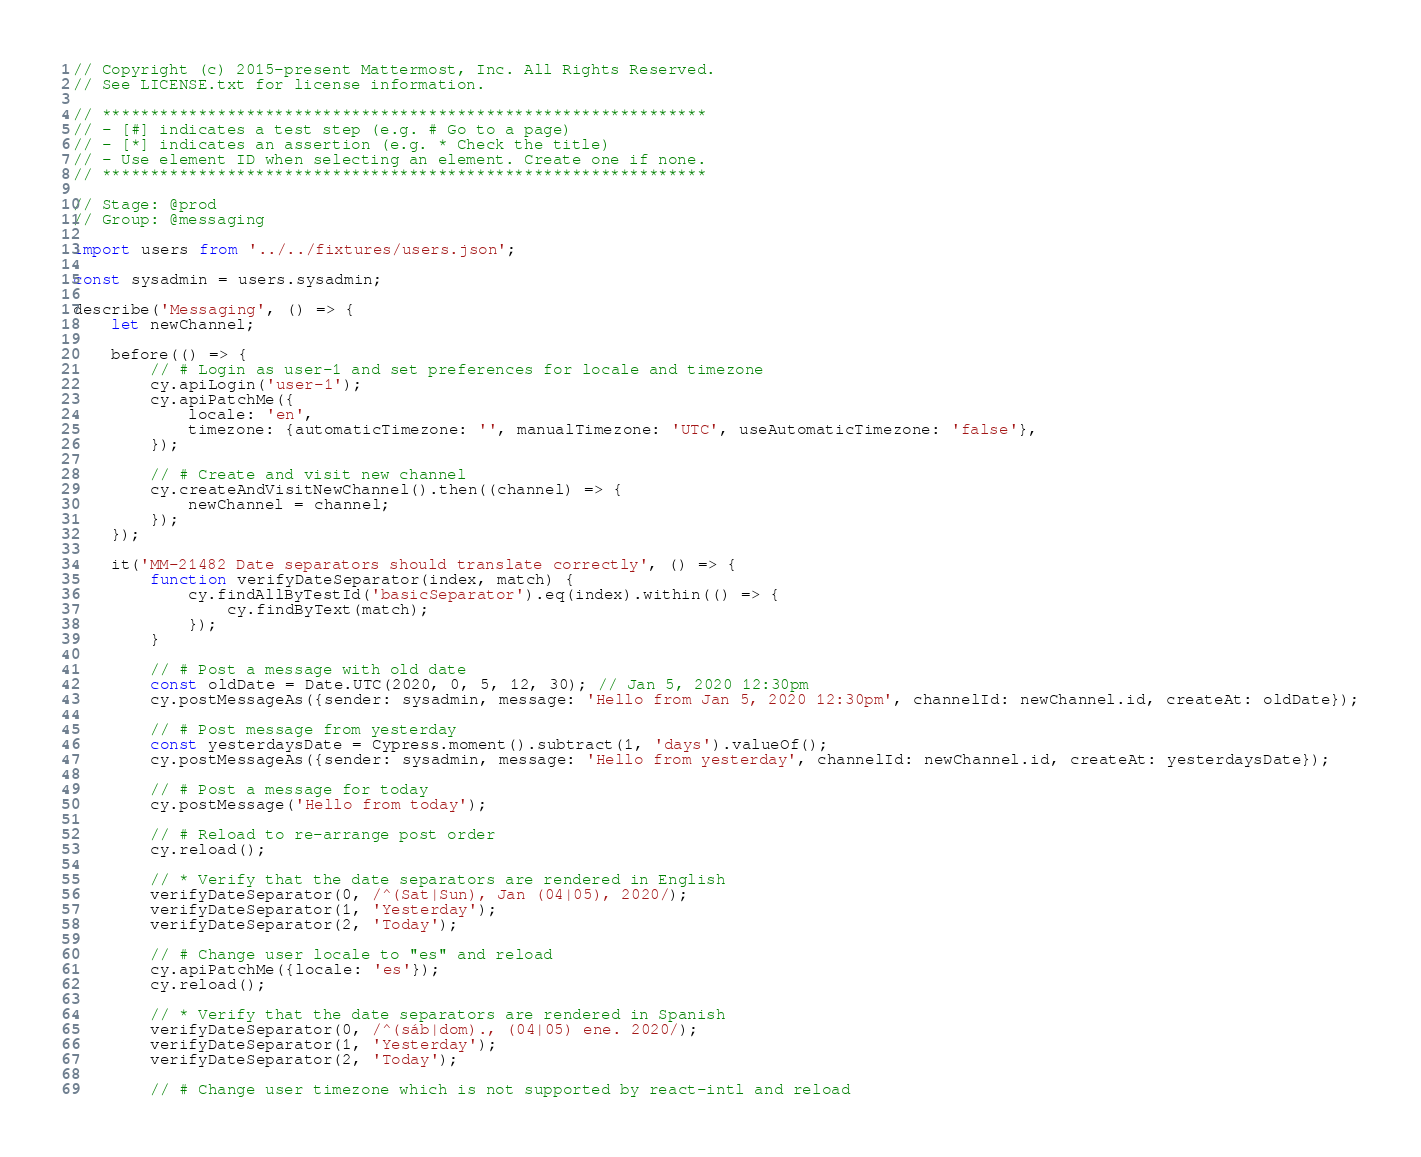<code> <loc_0><loc_0><loc_500><loc_500><_JavaScript_>// Copyright (c) 2015-present Mattermost, Inc. All Rights Reserved.
// See LICENSE.txt for license information.

// ***************************************************************
// - [#] indicates a test step (e.g. # Go to a page)
// - [*] indicates an assertion (e.g. * Check the title)
// - Use element ID when selecting an element. Create one if none.
// ***************************************************************

// Stage: @prod
// Group: @messaging

import users from '../../fixtures/users.json';

const sysadmin = users.sysadmin;

describe('Messaging', () => {
    let newChannel;

    before(() => {
        // # Login as user-1 and set preferences for locale and timezone
        cy.apiLogin('user-1');
        cy.apiPatchMe({
            locale: 'en',
            timezone: {automaticTimezone: '', manualTimezone: 'UTC', useAutomaticTimezone: 'false'},
        });

        // # Create and visit new channel
        cy.createAndVisitNewChannel().then((channel) => {
            newChannel = channel;
        });
    });

    it('MM-21482 Date separators should translate correctly', () => {
        function verifyDateSeparator(index, match) {
            cy.findAllByTestId('basicSeparator').eq(index).within(() => {
                cy.findByText(match);
            });
        }

        // # Post a message with old date
        const oldDate = Date.UTC(2020, 0, 5, 12, 30); // Jan 5, 2020 12:30pm
        cy.postMessageAs({sender: sysadmin, message: 'Hello from Jan 5, 2020 12:30pm', channelId: newChannel.id, createAt: oldDate});

        // # Post message from yesterday
        const yesterdaysDate = Cypress.moment().subtract(1, 'days').valueOf();
        cy.postMessageAs({sender: sysadmin, message: 'Hello from yesterday', channelId: newChannel.id, createAt: yesterdaysDate});

        // # Post a message for today
        cy.postMessage('Hello from today');

        // # Reload to re-arrange post order
        cy.reload();

        // * Verify that the date separators are rendered in English
        verifyDateSeparator(0, /^(Sat|Sun), Jan (04|05), 2020/);
        verifyDateSeparator(1, 'Yesterday');
        verifyDateSeparator(2, 'Today');

        // # Change user locale to "es" and reload
        cy.apiPatchMe({locale: 'es'});
        cy.reload();

        // * Verify that the date separators are rendered in Spanish
        verifyDateSeparator(0, /^(sáb|dom)., (04|05) ene. 2020/);
        verifyDateSeparator(1, 'Yesterday');
        verifyDateSeparator(2, 'Today');

        // # Change user timezone which is not supported by react-intl and reload</code> 